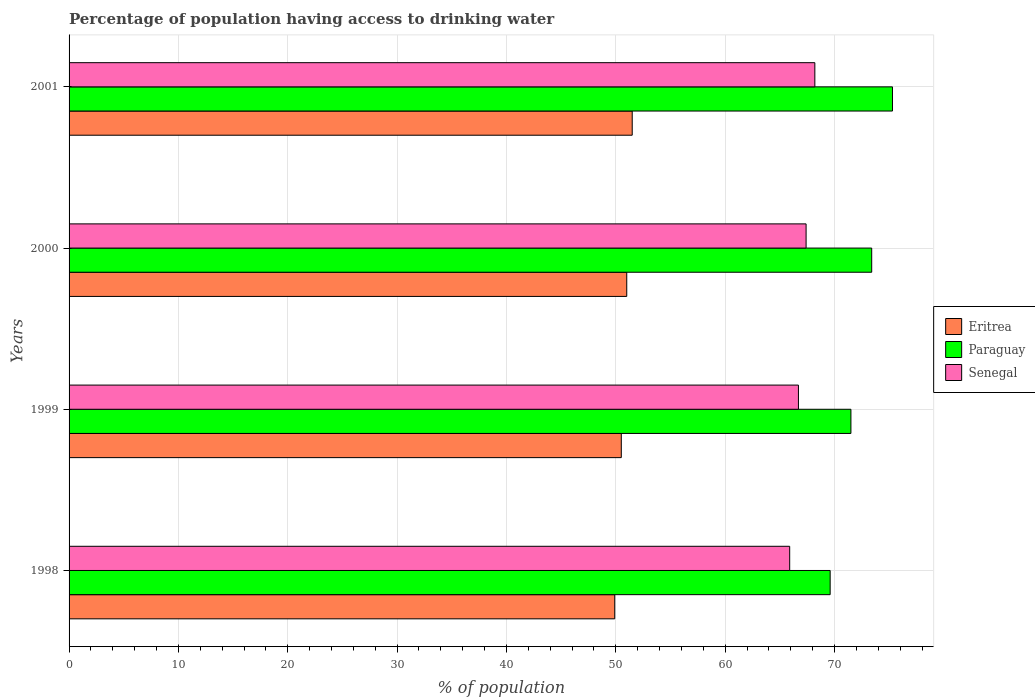How many groups of bars are there?
Your answer should be very brief. 4. Are the number of bars per tick equal to the number of legend labels?
Your answer should be compact. Yes. Are the number of bars on each tick of the Y-axis equal?
Make the answer very short. Yes. How many bars are there on the 2nd tick from the bottom?
Offer a terse response. 3. What is the percentage of population having access to drinking water in Paraguay in 2000?
Offer a very short reply. 73.4. Across all years, what is the maximum percentage of population having access to drinking water in Senegal?
Ensure brevity in your answer.  68.2. Across all years, what is the minimum percentage of population having access to drinking water in Eritrea?
Your response must be concise. 49.9. In which year was the percentage of population having access to drinking water in Eritrea maximum?
Offer a very short reply. 2001. In which year was the percentage of population having access to drinking water in Senegal minimum?
Your answer should be compact. 1998. What is the total percentage of population having access to drinking water in Eritrea in the graph?
Your answer should be very brief. 202.9. What is the difference between the percentage of population having access to drinking water in Paraguay in 1998 and that in 2000?
Your answer should be compact. -3.8. What is the difference between the percentage of population having access to drinking water in Senegal in 1999 and the percentage of population having access to drinking water in Eritrea in 2001?
Make the answer very short. 15.2. What is the average percentage of population having access to drinking water in Senegal per year?
Your response must be concise. 67.05. In the year 1998, what is the difference between the percentage of population having access to drinking water in Eritrea and percentage of population having access to drinking water in Senegal?
Offer a terse response. -16. In how many years, is the percentage of population having access to drinking water in Eritrea greater than 64 %?
Make the answer very short. 0. What is the ratio of the percentage of population having access to drinking water in Senegal in 1999 to that in 2001?
Provide a succinct answer. 0.98. Is the percentage of population having access to drinking water in Paraguay in 2000 less than that in 2001?
Your answer should be very brief. Yes. Is the difference between the percentage of population having access to drinking water in Eritrea in 1998 and 1999 greater than the difference between the percentage of population having access to drinking water in Senegal in 1998 and 1999?
Ensure brevity in your answer.  Yes. What is the difference between the highest and the second highest percentage of population having access to drinking water in Senegal?
Provide a succinct answer. 0.8. What is the difference between the highest and the lowest percentage of population having access to drinking water in Paraguay?
Make the answer very short. 5.7. In how many years, is the percentage of population having access to drinking water in Paraguay greater than the average percentage of population having access to drinking water in Paraguay taken over all years?
Provide a succinct answer. 2. Is the sum of the percentage of population having access to drinking water in Paraguay in 2000 and 2001 greater than the maximum percentage of population having access to drinking water in Eritrea across all years?
Ensure brevity in your answer.  Yes. What does the 2nd bar from the top in 2001 represents?
Offer a very short reply. Paraguay. What does the 3rd bar from the bottom in 1998 represents?
Provide a short and direct response. Senegal. Is it the case that in every year, the sum of the percentage of population having access to drinking water in Senegal and percentage of population having access to drinking water in Eritrea is greater than the percentage of population having access to drinking water in Paraguay?
Give a very brief answer. Yes. How many bars are there?
Your answer should be compact. 12. How many years are there in the graph?
Offer a terse response. 4. Are the values on the major ticks of X-axis written in scientific E-notation?
Give a very brief answer. No. Does the graph contain any zero values?
Your response must be concise. No. What is the title of the graph?
Make the answer very short. Percentage of population having access to drinking water. Does "Suriname" appear as one of the legend labels in the graph?
Offer a terse response. No. What is the label or title of the X-axis?
Your response must be concise. % of population. What is the label or title of the Y-axis?
Keep it short and to the point. Years. What is the % of population in Eritrea in 1998?
Offer a terse response. 49.9. What is the % of population in Paraguay in 1998?
Ensure brevity in your answer.  69.6. What is the % of population in Senegal in 1998?
Offer a terse response. 65.9. What is the % of population of Eritrea in 1999?
Provide a succinct answer. 50.5. What is the % of population in Paraguay in 1999?
Provide a succinct answer. 71.5. What is the % of population of Senegal in 1999?
Offer a terse response. 66.7. What is the % of population in Eritrea in 2000?
Provide a short and direct response. 51. What is the % of population in Paraguay in 2000?
Offer a very short reply. 73.4. What is the % of population of Senegal in 2000?
Provide a succinct answer. 67.4. What is the % of population of Eritrea in 2001?
Your response must be concise. 51.5. What is the % of population of Paraguay in 2001?
Keep it short and to the point. 75.3. What is the % of population of Senegal in 2001?
Ensure brevity in your answer.  68.2. Across all years, what is the maximum % of population in Eritrea?
Your response must be concise. 51.5. Across all years, what is the maximum % of population in Paraguay?
Make the answer very short. 75.3. Across all years, what is the maximum % of population of Senegal?
Offer a very short reply. 68.2. Across all years, what is the minimum % of population in Eritrea?
Provide a short and direct response. 49.9. Across all years, what is the minimum % of population in Paraguay?
Keep it short and to the point. 69.6. Across all years, what is the minimum % of population in Senegal?
Make the answer very short. 65.9. What is the total % of population of Eritrea in the graph?
Your response must be concise. 202.9. What is the total % of population in Paraguay in the graph?
Give a very brief answer. 289.8. What is the total % of population of Senegal in the graph?
Provide a short and direct response. 268.2. What is the difference between the % of population of Eritrea in 1998 and that in 1999?
Your response must be concise. -0.6. What is the difference between the % of population of Paraguay in 1998 and that in 1999?
Your answer should be very brief. -1.9. What is the difference between the % of population in Paraguay in 1998 and that in 2000?
Your response must be concise. -3.8. What is the difference between the % of population of Eritrea in 1998 and that in 2001?
Your answer should be very brief. -1.6. What is the difference between the % of population in Eritrea in 1999 and that in 2000?
Your response must be concise. -0.5. What is the difference between the % of population of Eritrea in 1999 and that in 2001?
Make the answer very short. -1. What is the difference between the % of population in Senegal in 1999 and that in 2001?
Offer a very short reply. -1.5. What is the difference between the % of population of Eritrea in 2000 and that in 2001?
Provide a short and direct response. -0.5. What is the difference between the % of population in Eritrea in 1998 and the % of population in Paraguay in 1999?
Make the answer very short. -21.6. What is the difference between the % of population in Eritrea in 1998 and the % of population in Senegal in 1999?
Give a very brief answer. -16.8. What is the difference between the % of population in Eritrea in 1998 and the % of population in Paraguay in 2000?
Offer a terse response. -23.5. What is the difference between the % of population of Eritrea in 1998 and the % of population of Senegal in 2000?
Your answer should be very brief. -17.5. What is the difference between the % of population of Eritrea in 1998 and the % of population of Paraguay in 2001?
Keep it short and to the point. -25.4. What is the difference between the % of population of Eritrea in 1998 and the % of population of Senegal in 2001?
Your answer should be very brief. -18.3. What is the difference between the % of population of Paraguay in 1998 and the % of population of Senegal in 2001?
Offer a terse response. 1.4. What is the difference between the % of population in Eritrea in 1999 and the % of population in Paraguay in 2000?
Give a very brief answer. -22.9. What is the difference between the % of population in Eritrea in 1999 and the % of population in Senegal in 2000?
Ensure brevity in your answer.  -16.9. What is the difference between the % of population of Paraguay in 1999 and the % of population of Senegal in 2000?
Offer a terse response. 4.1. What is the difference between the % of population of Eritrea in 1999 and the % of population of Paraguay in 2001?
Provide a short and direct response. -24.8. What is the difference between the % of population of Eritrea in 1999 and the % of population of Senegal in 2001?
Your response must be concise. -17.7. What is the difference between the % of population in Eritrea in 2000 and the % of population in Paraguay in 2001?
Provide a succinct answer. -24.3. What is the difference between the % of population in Eritrea in 2000 and the % of population in Senegal in 2001?
Provide a short and direct response. -17.2. What is the average % of population in Eritrea per year?
Keep it short and to the point. 50.73. What is the average % of population of Paraguay per year?
Make the answer very short. 72.45. What is the average % of population of Senegal per year?
Keep it short and to the point. 67.05. In the year 1998, what is the difference between the % of population of Eritrea and % of population of Paraguay?
Offer a terse response. -19.7. In the year 1999, what is the difference between the % of population in Eritrea and % of population in Senegal?
Your answer should be very brief. -16.2. In the year 2000, what is the difference between the % of population in Eritrea and % of population in Paraguay?
Provide a short and direct response. -22.4. In the year 2000, what is the difference between the % of population in Eritrea and % of population in Senegal?
Offer a very short reply. -16.4. In the year 2000, what is the difference between the % of population in Paraguay and % of population in Senegal?
Provide a succinct answer. 6. In the year 2001, what is the difference between the % of population of Eritrea and % of population of Paraguay?
Give a very brief answer. -23.8. In the year 2001, what is the difference between the % of population in Eritrea and % of population in Senegal?
Your answer should be very brief. -16.7. In the year 2001, what is the difference between the % of population in Paraguay and % of population in Senegal?
Your response must be concise. 7.1. What is the ratio of the % of population in Eritrea in 1998 to that in 1999?
Give a very brief answer. 0.99. What is the ratio of the % of population in Paraguay in 1998 to that in 1999?
Your response must be concise. 0.97. What is the ratio of the % of population of Eritrea in 1998 to that in 2000?
Your answer should be compact. 0.98. What is the ratio of the % of population in Paraguay in 1998 to that in 2000?
Give a very brief answer. 0.95. What is the ratio of the % of population of Senegal in 1998 to that in 2000?
Offer a very short reply. 0.98. What is the ratio of the % of population in Eritrea in 1998 to that in 2001?
Your response must be concise. 0.97. What is the ratio of the % of population of Paraguay in 1998 to that in 2001?
Your answer should be compact. 0.92. What is the ratio of the % of population in Senegal in 1998 to that in 2001?
Your answer should be compact. 0.97. What is the ratio of the % of population of Eritrea in 1999 to that in 2000?
Your response must be concise. 0.99. What is the ratio of the % of population in Paraguay in 1999 to that in 2000?
Give a very brief answer. 0.97. What is the ratio of the % of population in Senegal in 1999 to that in 2000?
Offer a very short reply. 0.99. What is the ratio of the % of population of Eritrea in 1999 to that in 2001?
Offer a terse response. 0.98. What is the ratio of the % of population in Paraguay in 1999 to that in 2001?
Your answer should be compact. 0.95. What is the ratio of the % of population of Senegal in 1999 to that in 2001?
Your response must be concise. 0.98. What is the ratio of the % of population of Eritrea in 2000 to that in 2001?
Your answer should be very brief. 0.99. What is the ratio of the % of population of Paraguay in 2000 to that in 2001?
Offer a terse response. 0.97. What is the ratio of the % of population of Senegal in 2000 to that in 2001?
Your answer should be very brief. 0.99. What is the difference between the highest and the second highest % of population of Senegal?
Give a very brief answer. 0.8. What is the difference between the highest and the lowest % of population in Paraguay?
Offer a very short reply. 5.7. What is the difference between the highest and the lowest % of population in Senegal?
Your answer should be very brief. 2.3. 